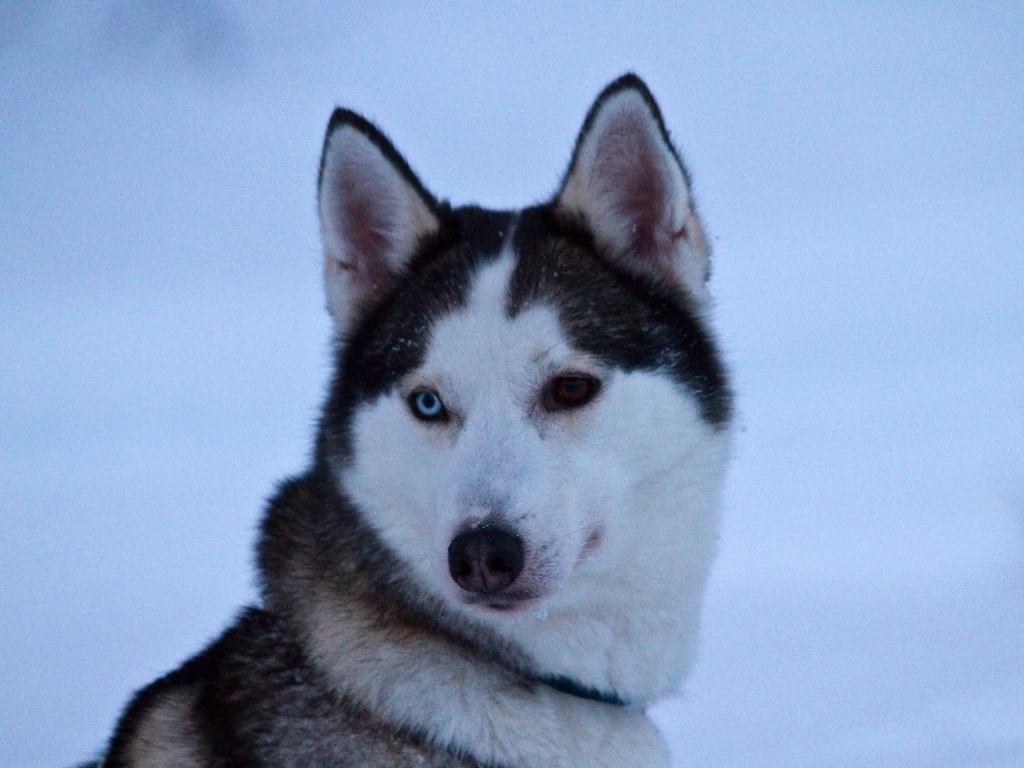What breed of dog is shown in the image? The dog in the image is a Siberian Husky, a breed known for its resilience and suitability for cold climates, as well as its friendly disposition. 